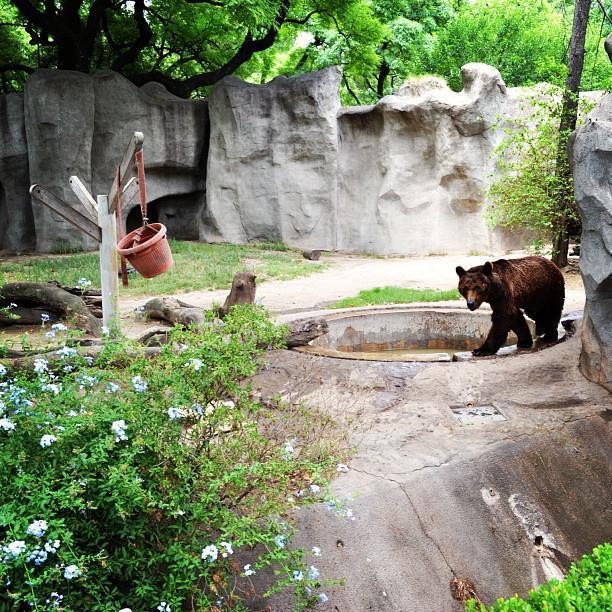How many bears are there?
Give a very brief answer. 1. How many people are not sitting?
Give a very brief answer. 0. 